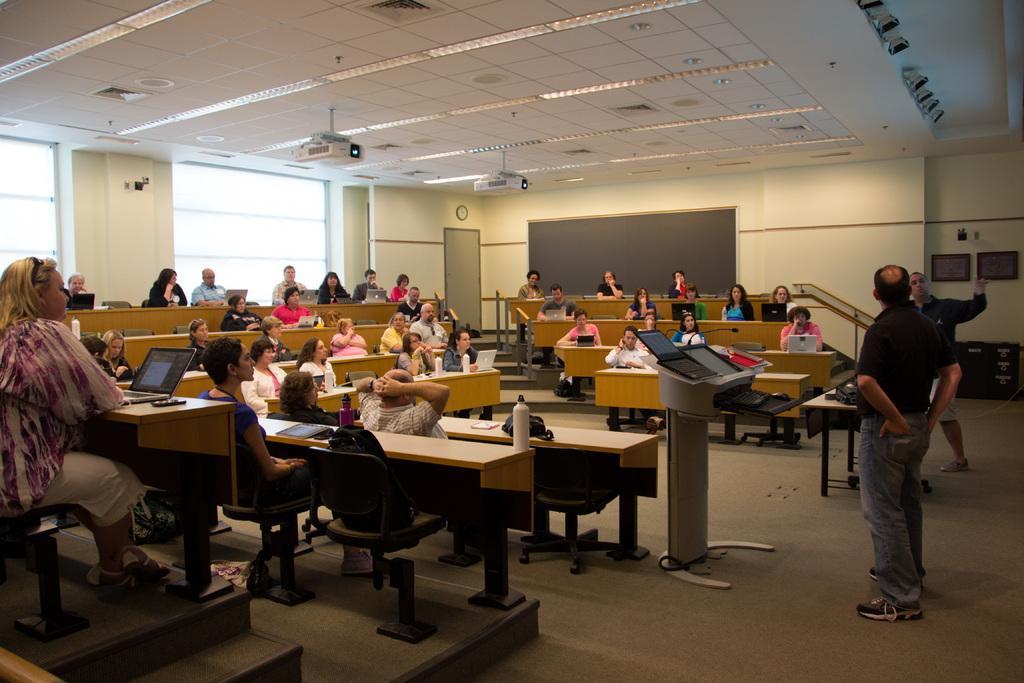Describe this image in one or two sentences. In this picture there are a group of people sitting and they have a laptop in front of them there are two people standing here 